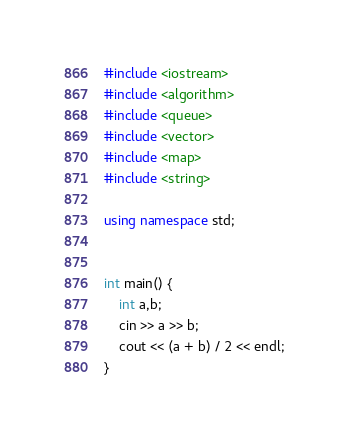Convert code to text. <code><loc_0><loc_0><loc_500><loc_500><_C++_>#include <iostream>
#include <algorithm>
#include <queue>
#include <vector>
#include <map>
#include <string>

using namespace std;


int main() {
    int a,b;
    cin >> a >> b;
    cout << (a + b) / 2 << endl;
}</code> 